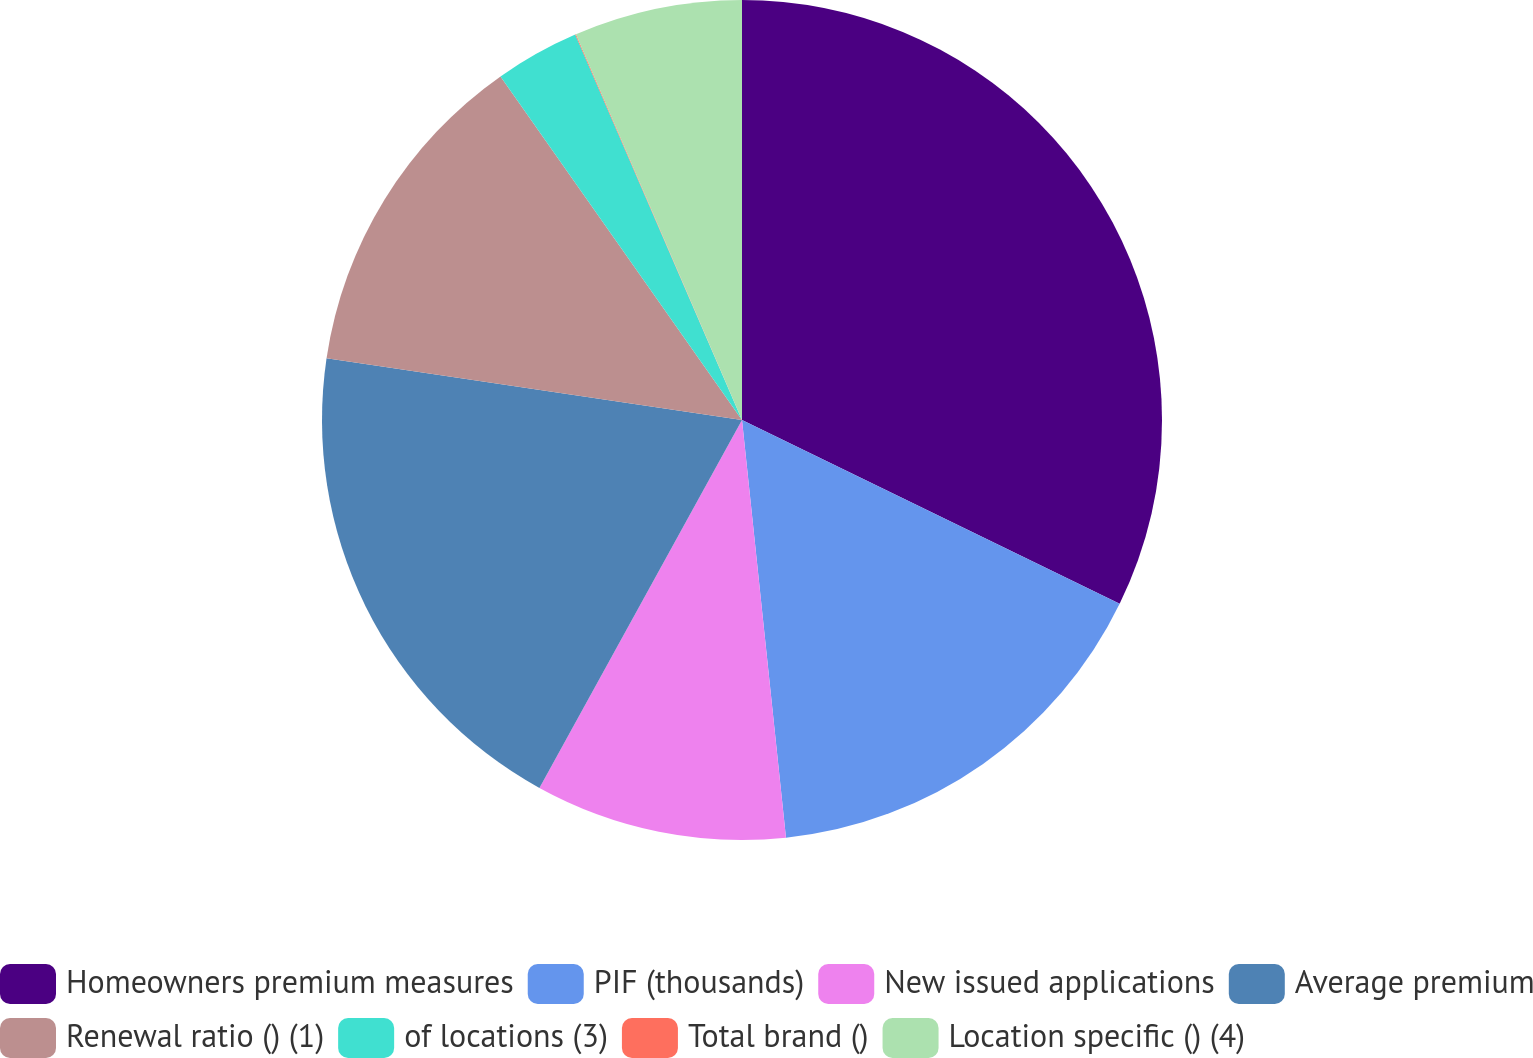Convert chart to OTSL. <chart><loc_0><loc_0><loc_500><loc_500><pie_chart><fcel>Homeowners premium measures<fcel>PIF (thousands)<fcel>New issued applications<fcel>Average premium<fcel>Renewal ratio () (1)<fcel>of locations (3)<fcel>Total brand ()<fcel>Location specific () (4)<nl><fcel>32.21%<fcel>16.12%<fcel>9.68%<fcel>19.34%<fcel>12.9%<fcel>3.25%<fcel>0.03%<fcel>6.47%<nl></chart> 